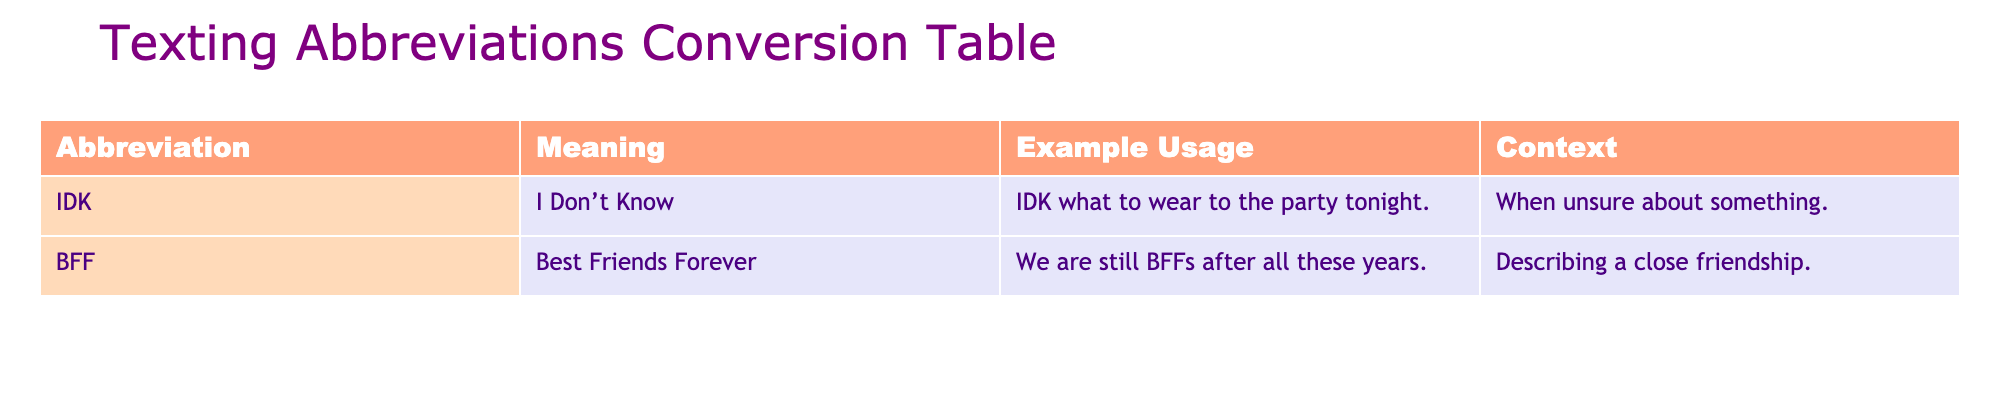What does IDK stand for? The abbreviation IDK is in the table under the "Abbreviation" column, and it corresponds to the meaning given in the "Meaning" column. Therefore, IDK stands for "I Don’t Know."
Answer: I Don’t Know Can you give an example of how BFF is used? In the table, under the "Example Usage" column for the abbreviation BFF, there is a sentence: "We are still BFFs after all these years." This shows how it can be used in a sentence.
Answer: We are still BFFs after all these years Is the abbreviation IDK used when someone is unsure? By checking the "Context" column next to the abbreviation IDK, we see that it states, "When unsure about something." This confirms that IDK is indeed used in contexts of uncertainty.
Answer: Yes Which abbreviation refers to a close friendship? Looking at the "Meaning" column, BFF is defined as "Best Friends Forever," which directly references a close friendship. Therefore, BFF is the abbreviation that refers to this type of relationship.
Answer: BFF If someone says IDK about a question, what does it imply? Referring to the context of the abbreviation IDK, it implies that the person does not have the answer or is unsure about something. This is understood from the context provided in the table.
Answer: It implies that they are unsure or don’t have the answer Are both abbreviations found in the context of friendships? The table specifies that IDK is used when unsure about something, while BFF explicitly refers to a close friendship. Since IDK does not relate to friendship, the answer combines both observations.
Answer: No, only BFF relates to friendships What is the common theme in the context of both abbreviations? Looking at the "Context" columns, IDK is used for uncertainty and BFF is about friendship. The common theme revolves around interpersonal communications but in different contexts: uncertainty versus closeness.
Answer: Interpersonal communication If someone is describing a long-lasting friendship, which abbreviation would they likely use? In the table, BFF is defined as "Best Friends Forever," indicating a long-lasting friendship. Therefore, if someone is describing such a relationship, they would use BFF.
Answer: BFF 